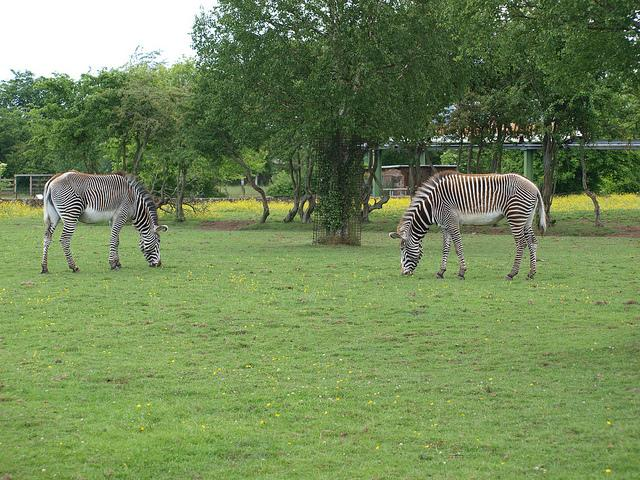The zebras in the middle of the field are busy doing what?

Choices:
A) running
B) walking
C) eating grass
D) pointing nose eating grass 